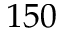Convert formula to latex. <formula><loc_0><loc_0><loc_500><loc_500>1 5 0</formula> 